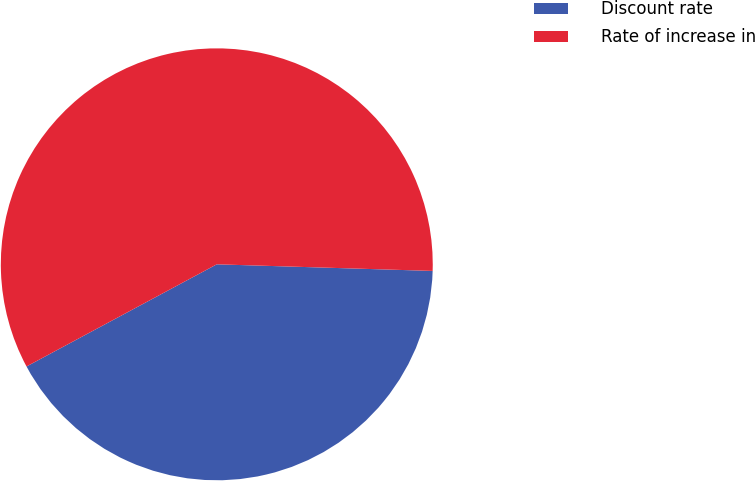<chart> <loc_0><loc_0><loc_500><loc_500><pie_chart><fcel>Discount rate<fcel>Rate of increase in<nl><fcel>41.67%<fcel>58.33%<nl></chart> 